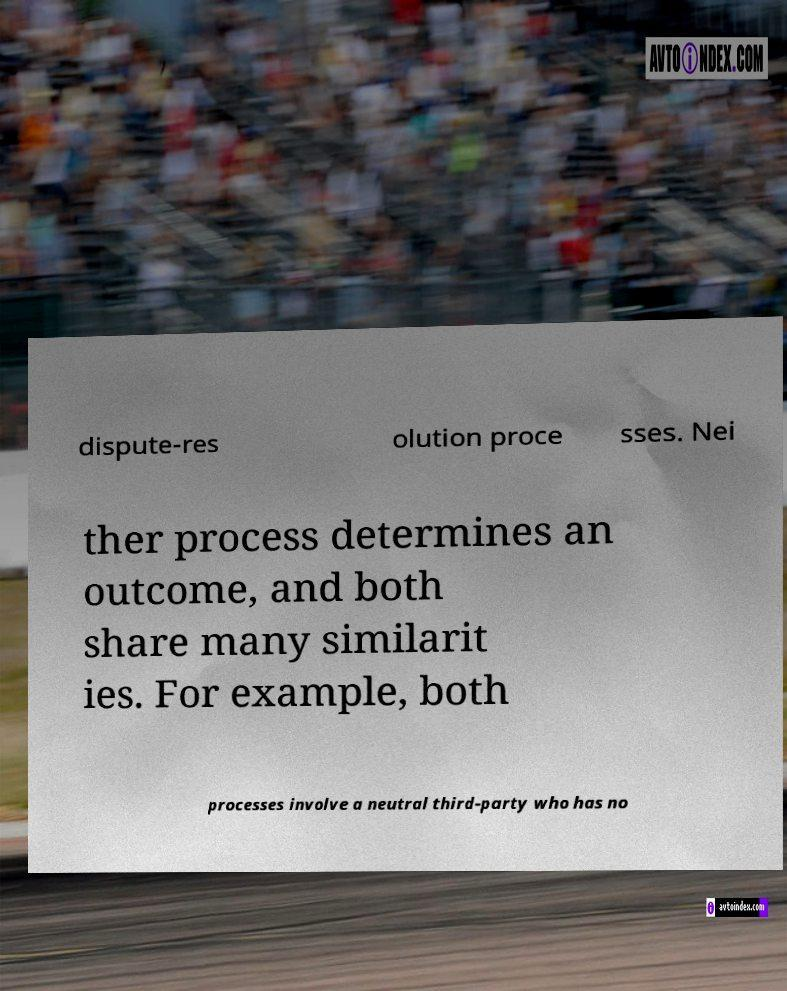For documentation purposes, I need the text within this image transcribed. Could you provide that? dispute-res olution proce sses. Nei ther process determines an outcome, and both share many similarit ies. For example, both processes involve a neutral third-party who has no 